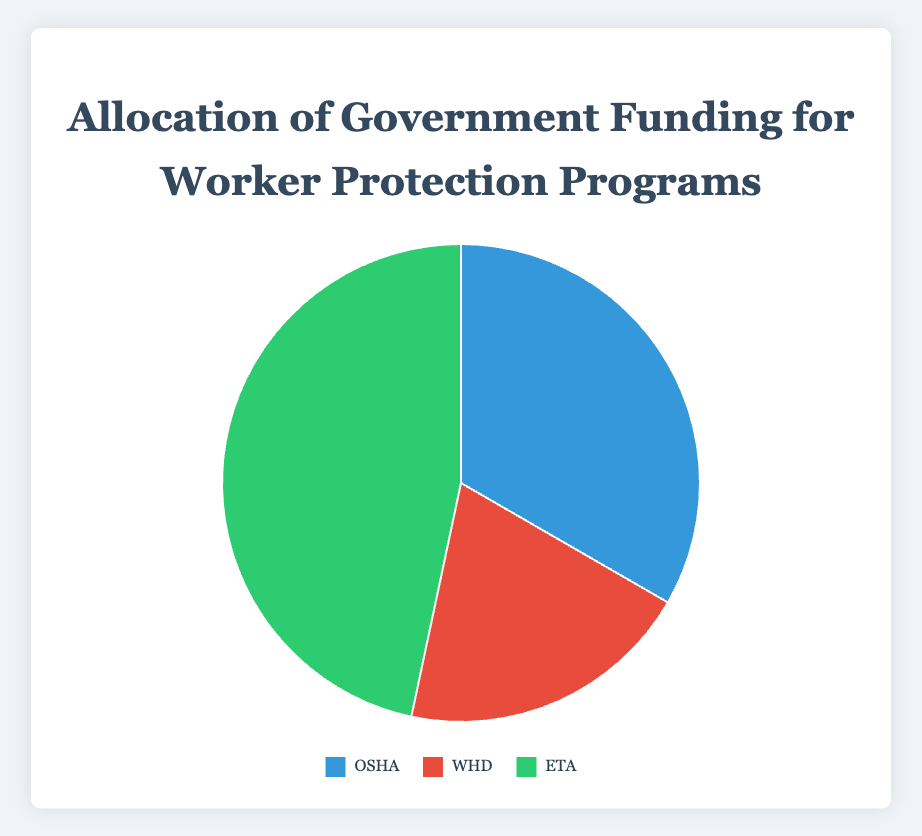What is the total government funding allocated to worker protection programs? The total funding can be calculated by summing the amounts allocated to each program. Occupational Safety gets $250,000,000, Wage Enforcement gets $150,000,000, and Job Training gets $350,000,000. So, the total funding is $250,000,000 + $150,000,000 + $350,000,000 = $750,000,000.
Answer: $750,000,000 Which program receives the highest funding? By comparing the funding amounts for each program, Job Training (ETA) receives $350,000,000, which is higher than both Occupational Safety's $250,000,000 and Wage Enforcement's $150,000,000.
Answer: Job Training (ETA) What is the percentage of the total funding allocated to the Wage and Hour Division (WHD)? The percentage can be calculated by dividing WHD's funding by the total funding and multiplying by 100. WHD's funding is $150,000,000, and the total is $750,000,000. So, ($150,000,000 / $750,000,000) * 100 = 20%.
Answer: 20% How much more funding does Job Training (ETA) receive compared to Wage Enforcement (WHD)? The difference in funding can be found by subtracting WHD's funding from ETA's funding. ETA receives $350,000,000 and WHD receives $150,000,000. So, $350,000,000 - $150,000,000 = $200,000,000.
Answer: $200,000,000 If we were to reallocate $50,000,000 from Job Training (ETA) to Wage Enforcement (WHD), what would the new funding amounts be for each? Subtract $50,000,000 from ETA's funding and add it to WHD's funding. The new ETA funding would be $350,000,000 - $50,000,000 = $300,000,000. The new WHD funding would be $150,000,000 + $50,000,000 = $200,000,000.
Answer: ETA: $300,000,000, WHD: $200,000,000 What color represents the Occupational Safety and Health Administration (OSHA) in the pie chart? In the pie chart, OSHA is represented by the color blue.
Answer: Blue Which program receives the least funding, and how much is it? By examining the funding amounts, Wage Enforcement (WHD) receives the least amount of $150,000,000.
Answer: Wage Enforcement (WHD), $150,000,000 What is the combined percentage of funding allocated to Occupational Safety (OSHA) and Job Training (ETA)? The combined funding percentage can be calculated by adding the percentages of OSHA and ETA. OSHA gets 33.33% and ETA gets 46.67%. So, 33.33% + 46.67% = 80%.
Answer: 80% If the funding for each program is increased by 10%, what will be the new funding amount for each program? Increase each program's funding by 10%. OSHA: $250,000,000 * 1.1 = $275,000,000. WHD: $150,000,000 * 1.1 = $165,000,000. ETA: $350,000,000 * 1.1 = $385,000,000.
Answer: OSHA: $275,000,000, WHD: $165,000,000, ETA: $385,000,000 What is the visual representation (color and size) of the segment corresponding to Job Training (ETA) in the pie chart? The Job Training (ETA) segment is represented in green and occupies the largest portion of the pie chart.
Answer: Green and largest 